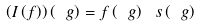Convert formula to latex. <formula><loc_0><loc_0><loc_500><loc_500>\left ( I \left ( f \right ) \right ) \left ( \ g \right ) = f \left ( \ g \right ) \ s \left ( \ g \right )</formula> 